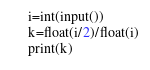Convert code to text. <code><loc_0><loc_0><loc_500><loc_500><_Python_>i=int(input())
k=float(i/2)/float(i)
print(k)</code> 